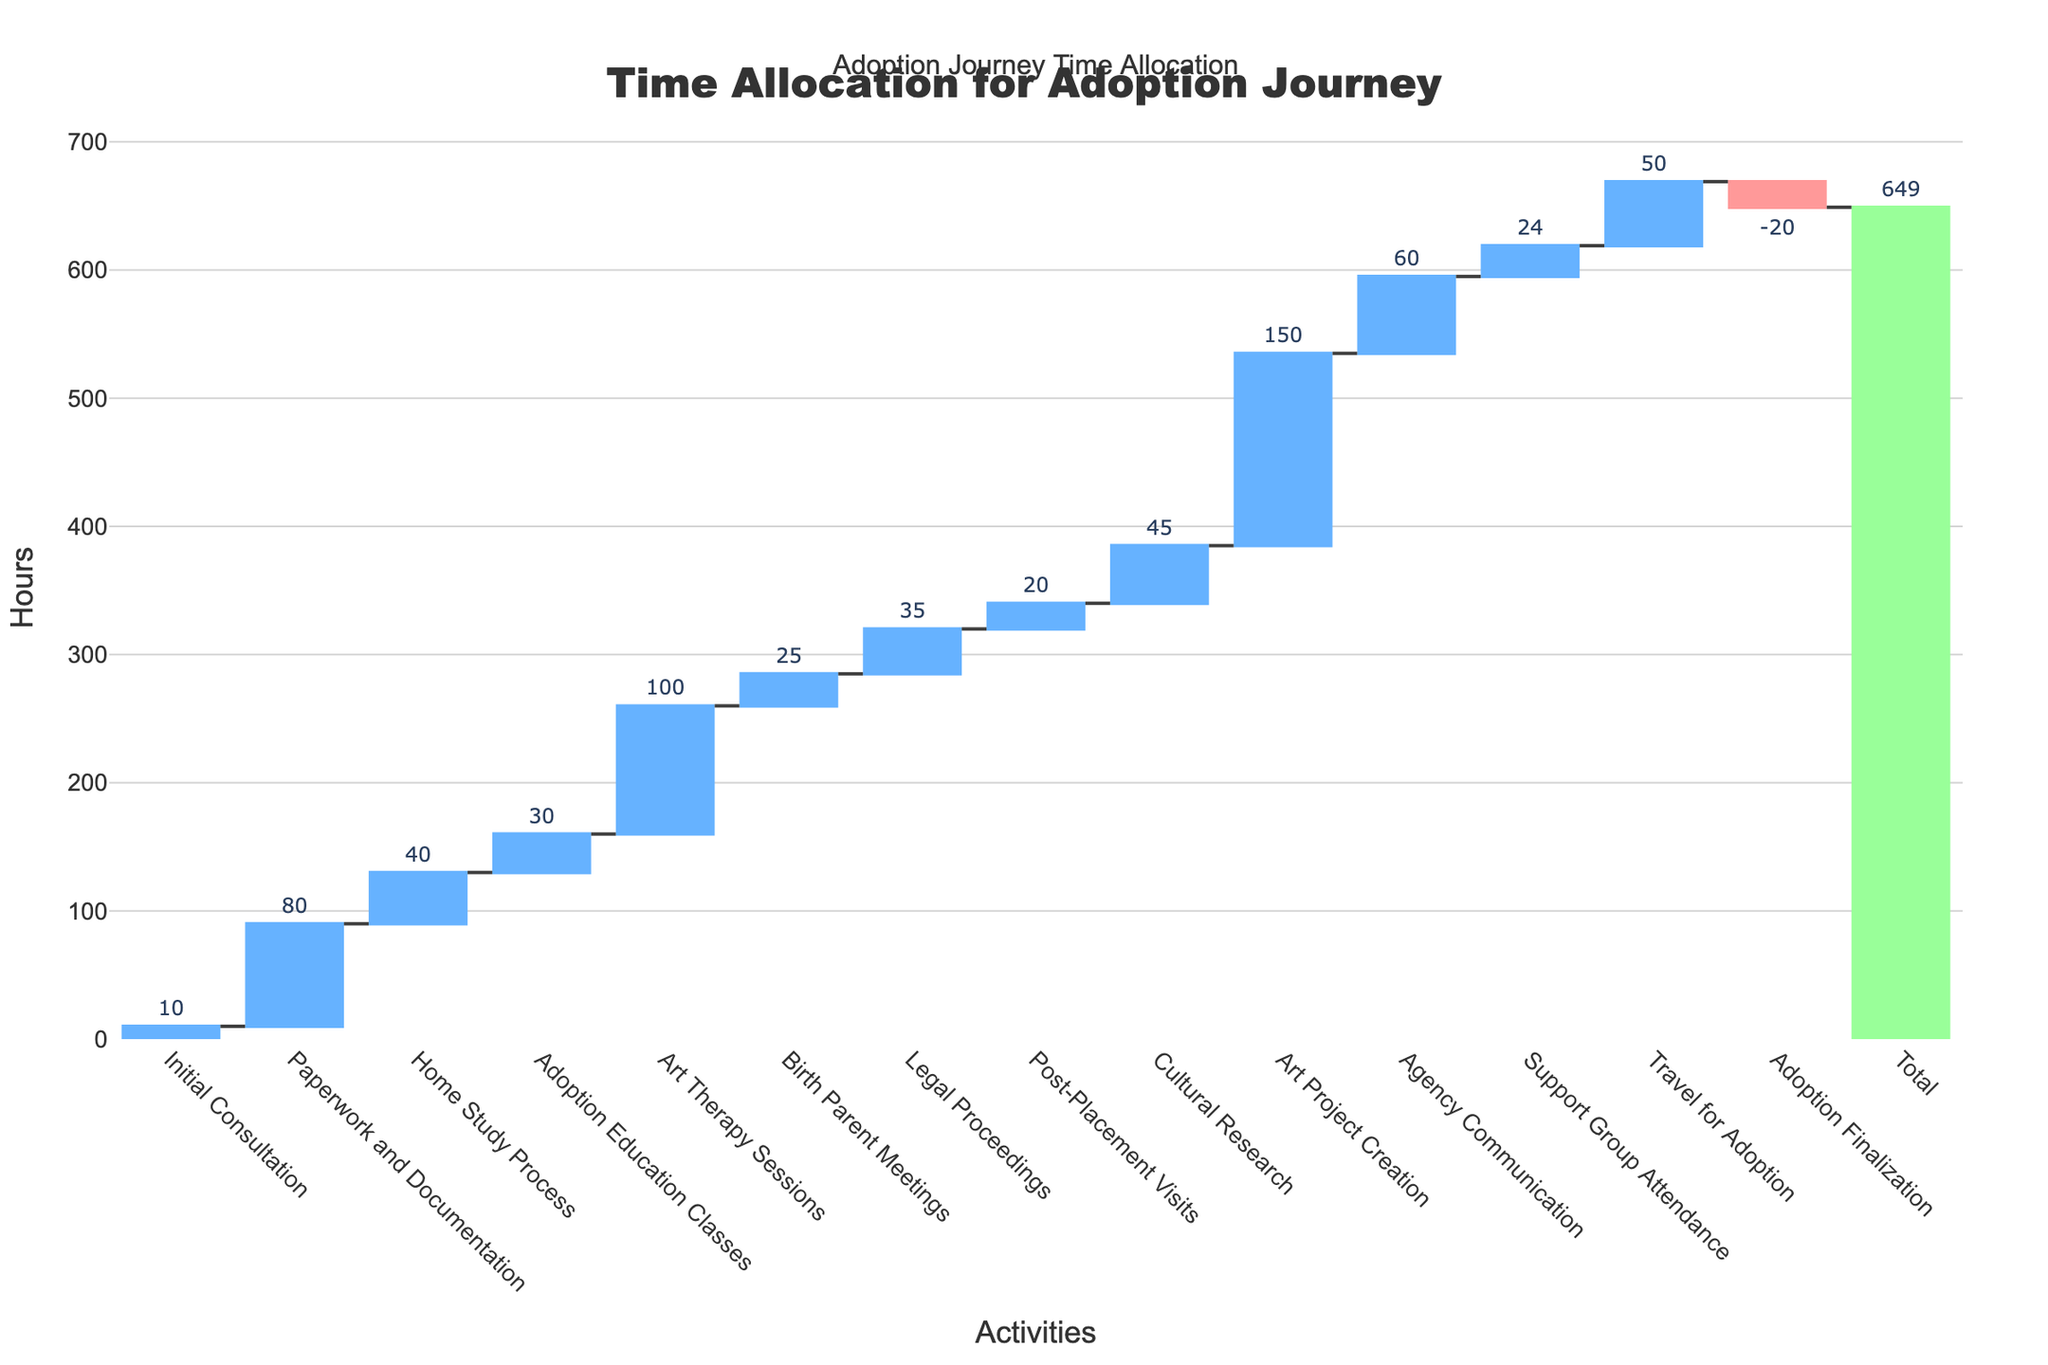What is the title of the chart? The title is located at the top of the chart. Reading it directly from the chart, it says "Time Allocation for Adoption Journey"
Answer: Time Allocation for Adoption Journey How many hours were spent on Art Project Creation? The hours for each activity are labeled on the chart. Locate "Art Project Creation" and read the corresponding number of hours.
Answer: 150 How many activities have a positive allocation of hours? Count the bars representing various activities, excluding the negative "Adoption Finalization," and the total.
Answer: 13 What is the difference in hours between Paperwork and Documentation and Art Therapy Sessions? The hours for Paperwork and Documentation are 80 and for Art Therapy Sessions are 100. Subtract the hours of Paperwork and Documentation from Art Therapy Sessions (100 - 80).
Answer: 20 Which activity has the smallest positive time allocation? Locate the activity with the smallest bar that is above the zero line. This is "Initial Consultation."
Answer: Initial Consultation Which two activities together have a combined time allocation equal to the hours spent on Travel for Adoption? Travel for Adoption is 50 hours. Find combinations that add up to 50. Support Group Attendance (24) and Initial Consultation (10) together sum up to 34, and adding another activity like Birth Parent Meetings (25) would exceed 50. Therefore, the correct combination of hours is Adoption Education Classes (30) and Post-Placement Visits (20).
Answer: Adoption Education Classes and Post-Placement Visits Which activity decreased the total time allocation, and by how many hours? The chart shows one negative bar, labeled "Adoption Finalization," which is the only activity reducing the total. The value is labeled on the bar as -20 hours.
Answer: Adoption Finalization, 20 hours Are more hours spent on Art Therapy Sessions or Agency Communication? Compare the height of the bars related to Art Therapy Sessions and Agency Communication. Art Therapy Sessions has 100 hours, whereas Agency Communication has 60 hours.
Answer: Art Therapy Sessions How does the total time spent on legal proceedings compare to the time spent on the home study process? Find and compare the values for "Legal Proceedings" (35 hours) and "Home Study Process" (40 hours). Legal Proceedings has fewer hours.
Answer: Legal Proceedings is less What is the cumulative time spent on Adoption Education Classes, Birth Parent Meetings, and Support Group Attendance? Find and sum the values: Adoption Education Classes (30), Birth Parent Meetings (25), and Support Group Attendance (24). Sum is 30 + 25 + 24 = 79.
Answer: 79 